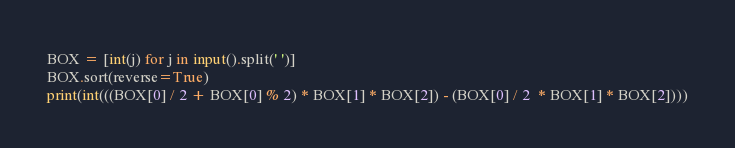Convert code to text. <code><loc_0><loc_0><loc_500><loc_500><_Python_>BOX = [int(j) for j in input().split(' ')]
BOX.sort(reverse=True)
print(int(((BOX[0] / 2 + BOX[0] % 2) * BOX[1] * BOX[2]) - (BOX[0] / 2  * BOX[1] * BOX[2])))
</code> 